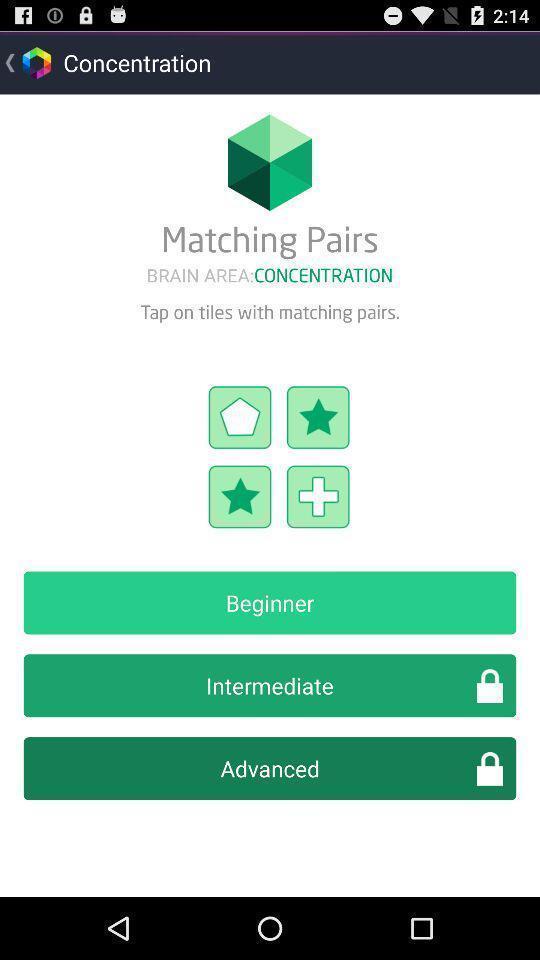What can you discern from this picture? Screen displaying the screen page of a brain training app. 